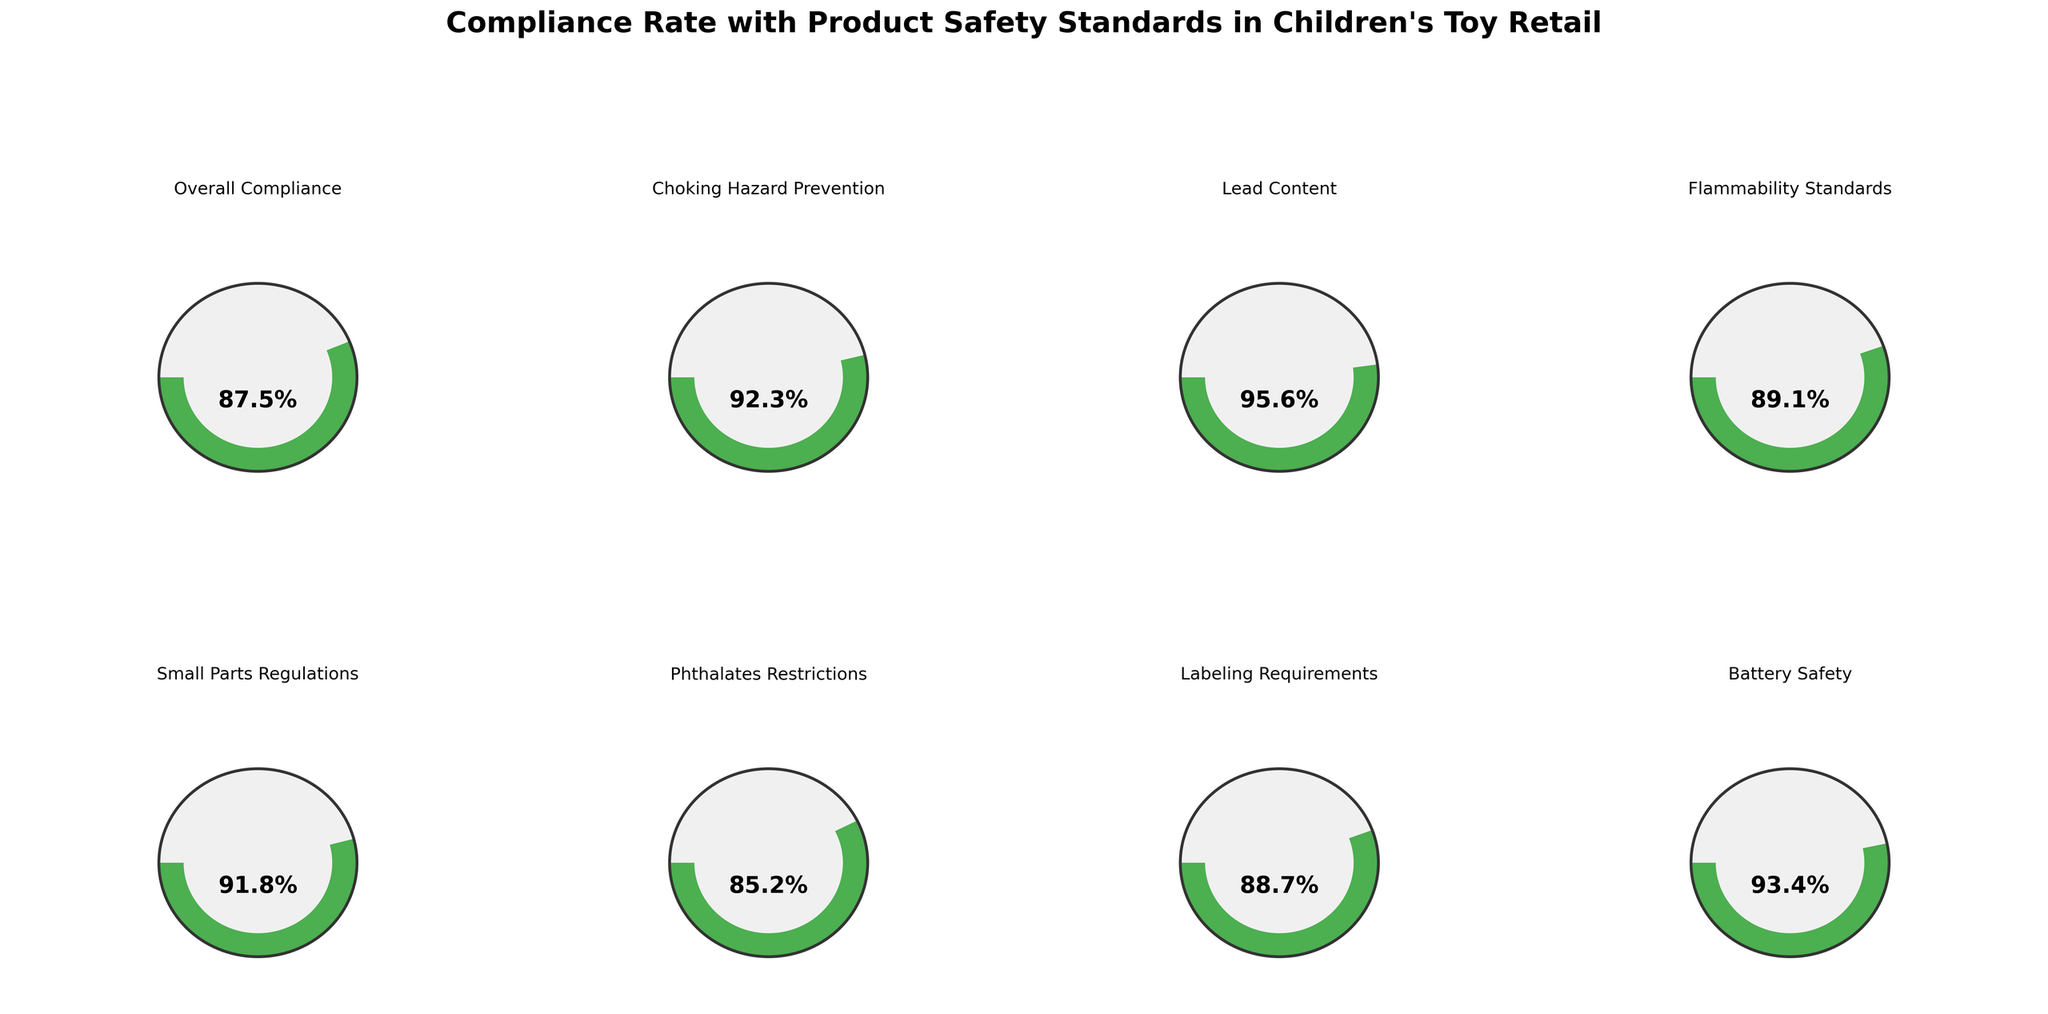What is the title of the figure? The title is usually positioned at the top of the figure and can be identified easily by locating the largest and boldest text.
Answer: Compliance Rate with Product Safety Standards in Children's Toy Retail Which category has the highest compliance rate? By comparing the listed compliance rates for each category, we can see that Lead Content has the highest compliance rate at 95.6%.
Answer: Lead Content Which category has the lowest compliance rate? By comparing the listed compliance rates for each category, we can see that Phthalates Restrictions has the lowest compliance rate at 85.2%.
Answer: Phthalates Restrictions What is the compliance rate for Battery Safety? By looking at the gauge chart and the value text associated with the Battery Safety category, we find that it is 93.4%.
Answer: 93.4% Are all the compliance rates above 85%? Check each compliance rate listed on the figure: Overall Compliance (87.5%), Choking Hazard Prevention (92.3%), Lead Content (95.6%), Flammability Standards (89.1%), Small Parts Regulations (91.8%), Phthalates Restrictions (85.2%), Labeling Requirements (88.7%), Battery Safety (93.4%). The lowest is 85.2%.
Answer: Yes How many categories have a compliance rate above 90%? Counting the individual categories that have a compliance rate above 90%: Choking Hazard Prevention (92.3%), Lead Content (95.6%), Small Parts Regulations (91.8%), Battery Safety (93.4%). There are 4 such categories.
Answer: 4 What is the average compliance rate across all categories? Sum the compliance rates and divide by the number of categories: (87.5 + 92.3 + 95.6 + 89.1 + 91.8 + 85.2 + 88.7 + 93.4) / 8 = 723.6 / 8 = 90.45%.
Answer: 90.45% Which specific safety standard falls below the overall compliance rate? Compare each category's compliance rate to the overall compliance rate of 87.5%. Phthalates Restrictions (85.2%) is the only category below this threshold.
Answer: Phthalates Restrictions Is there a substantial difference between the compliance rates of Choking Hazard Prevention and Small Parts Regulations? Subtract the compliance rate of Small Parts Regulations (91.8%) from that of Choking Hazard Prevention (92.3%): 92.3% - 91.8% = 0.5%. The difference is small.
Answer: No, the difference is small (0.5%) Which category's compliance rate is closest to 90%? Comparing the compliance rates to 90%, Flammability Standards (89.1%) is the closest.
Answer: Flammability Standards 